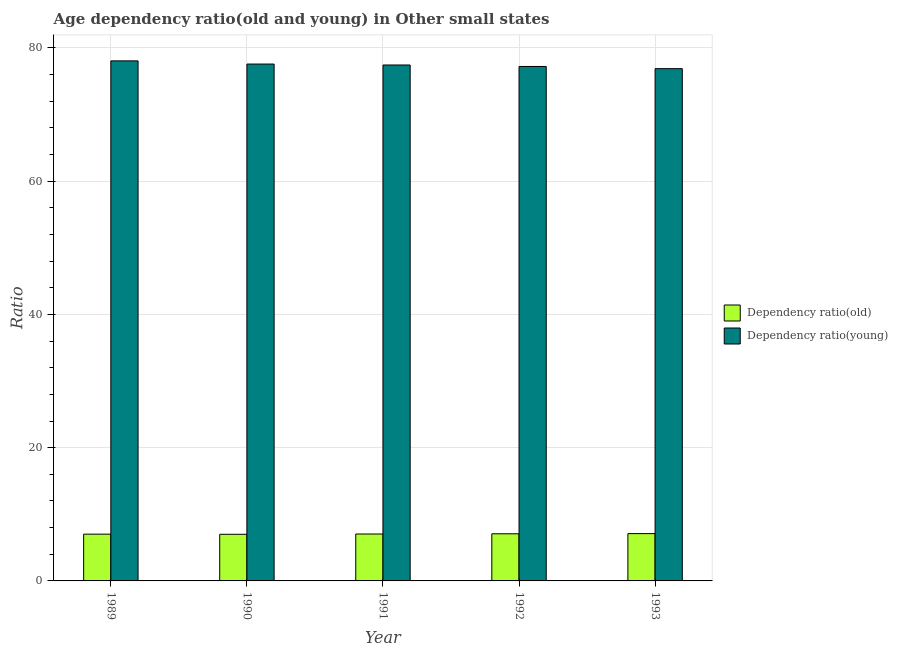How many different coloured bars are there?
Offer a terse response. 2. How many bars are there on the 4th tick from the left?
Make the answer very short. 2. What is the age dependency ratio(young) in 1991?
Provide a succinct answer. 77.45. Across all years, what is the maximum age dependency ratio(young)?
Make the answer very short. 78.07. Across all years, what is the minimum age dependency ratio(old)?
Ensure brevity in your answer.  7. In which year was the age dependency ratio(young) maximum?
Make the answer very short. 1989. What is the total age dependency ratio(young) in the graph?
Your answer should be very brief. 387.23. What is the difference between the age dependency ratio(old) in 1989 and that in 1990?
Give a very brief answer. 0.02. What is the difference between the age dependency ratio(old) in 1992 and the age dependency ratio(young) in 1989?
Give a very brief answer. 0.05. What is the average age dependency ratio(old) per year?
Your answer should be compact. 7.05. In how many years, is the age dependency ratio(old) greater than 24?
Your response must be concise. 0. What is the ratio of the age dependency ratio(old) in 1989 to that in 1990?
Provide a succinct answer. 1. Is the age dependency ratio(old) in 1991 less than that in 1992?
Keep it short and to the point. Yes. Is the difference between the age dependency ratio(old) in 1990 and 1991 greater than the difference between the age dependency ratio(young) in 1990 and 1991?
Provide a succinct answer. No. What is the difference between the highest and the second highest age dependency ratio(old)?
Your response must be concise. 0.02. What is the difference between the highest and the lowest age dependency ratio(young)?
Make the answer very short. 1.17. In how many years, is the age dependency ratio(old) greater than the average age dependency ratio(old) taken over all years?
Keep it short and to the point. 2. Is the sum of the age dependency ratio(old) in 1989 and 1990 greater than the maximum age dependency ratio(young) across all years?
Offer a very short reply. Yes. What does the 1st bar from the left in 1991 represents?
Offer a terse response. Dependency ratio(old). What does the 2nd bar from the right in 1993 represents?
Your answer should be compact. Dependency ratio(old). How many bars are there?
Your answer should be very brief. 10. Are all the bars in the graph horizontal?
Offer a very short reply. No. How many years are there in the graph?
Your answer should be compact. 5. What is the difference between two consecutive major ticks on the Y-axis?
Keep it short and to the point. 20. Does the graph contain any zero values?
Your answer should be very brief. No. Where does the legend appear in the graph?
Your response must be concise. Center right. How many legend labels are there?
Offer a very short reply. 2. What is the title of the graph?
Your answer should be very brief. Age dependency ratio(old and young) in Other small states. Does "Overweight" appear as one of the legend labels in the graph?
Offer a terse response. No. What is the label or title of the Y-axis?
Provide a short and direct response. Ratio. What is the Ratio in Dependency ratio(old) in 1989?
Give a very brief answer. 7.02. What is the Ratio in Dependency ratio(young) in 1989?
Offer a terse response. 78.07. What is the Ratio in Dependency ratio(old) in 1990?
Your answer should be very brief. 7. What is the Ratio in Dependency ratio(young) in 1990?
Offer a terse response. 77.59. What is the Ratio in Dependency ratio(old) in 1991?
Keep it short and to the point. 7.04. What is the Ratio of Dependency ratio(young) in 1991?
Offer a very short reply. 77.45. What is the Ratio of Dependency ratio(old) in 1992?
Make the answer very short. 7.08. What is the Ratio in Dependency ratio(young) in 1992?
Your response must be concise. 77.23. What is the Ratio in Dependency ratio(old) in 1993?
Offer a very short reply. 7.1. What is the Ratio in Dependency ratio(young) in 1993?
Provide a short and direct response. 76.9. Across all years, what is the maximum Ratio of Dependency ratio(old)?
Provide a short and direct response. 7.1. Across all years, what is the maximum Ratio in Dependency ratio(young)?
Provide a short and direct response. 78.07. Across all years, what is the minimum Ratio of Dependency ratio(old)?
Keep it short and to the point. 7. Across all years, what is the minimum Ratio of Dependency ratio(young)?
Keep it short and to the point. 76.9. What is the total Ratio of Dependency ratio(old) in the graph?
Keep it short and to the point. 35.24. What is the total Ratio in Dependency ratio(young) in the graph?
Give a very brief answer. 387.23. What is the difference between the Ratio of Dependency ratio(old) in 1989 and that in 1990?
Provide a short and direct response. 0.02. What is the difference between the Ratio of Dependency ratio(young) in 1989 and that in 1990?
Provide a short and direct response. 0.48. What is the difference between the Ratio in Dependency ratio(old) in 1989 and that in 1991?
Your answer should be compact. -0.02. What is the difference between the Ratio in Dependency ratio(young) in 1989 and that in 1991?
Provide a succinct answer. 0.62. What is the difference between the Ratio of Dependency ratio(old) in 1989 and that in 1992?
Provide a succinct answer. -0.05. What is the difference between the Ratio in Dependency ratio(young) in 1989 and that in 1992?
Give a very brief answer. 0.84. What is the difference between the Ratio in Dependency ratio(old) in 1989 and that in 1993?
Make the answer very short. -0.08. What is the difference between the Ratio of Dependency ratio(young) in 1989 and that in 1993?
Make the answer very short. 1.17. What is the difference between the Ratio in Dependency ratio(old) in 1990 and that in 1991?
Ensure brevity in your answer.  -0.04. What is the difference between the Ratio of Dependency ratio(young) in 1990 and that in 1991?
Keep it short and to the point. 0.14. What is the difference between the Ratio in Dependency ratio(old) in 1990 and that in 1992?
Provide a short and direct response. -0.08. What is the difference between the Ratio in Dependency ratio(young) in 1990 and that in 1992?
Your response must be concise. 0.37. What is the difference between the Ratio in Dependency ratio(old) in 1990 and that in 1993?
Your response must be concise. -0.1. What is the difference between the Ratio of Dependency ratio(young) in 1990 and that in 1993?
Your response must be concise. 0.69. What is the difference between the Ratio in Dependency ratio(old) in 1991 and that in 1992?
Offer a very short reply. -0.03. What is the difference between the Ratio in Dependency ratio(young) in 1991 and that in 1992?
Offer a very short reply. 0.22. What is the difference between the Ratio of Dependency ratio(old) in 1991 and that in 1993?
Make the answer very short. -0.06. What is the difference between the Ratio in Dependency ratio(young) in 1991 and that in 1993?
Provide a short and direct response. 0.55. What is the difference between the Ratio in Dependency ratio(old) in 1992 and that in 1993?
Offer a terse response. -0.02. What is the difference between the Ratio of Dependency ratio(young) in 1992 and that in 1993?
Make the answer very short. 0.33. What is the difference between the Ratio in Dependency ratio(old) in 1989 and the Ratio in Dependency ratio(young) in 1990?
Keep it short and to the point. -70.57. What is the difference between the Ratio of Dependency ratio(old) in 1989 and the Ratio of Dependency ratio(young) in 1991?
Provide a short and direct response. -70.43. What is the difference between the Ratio in Dependency ratio(old) in 1989 and the Ratio in Dependency ratio(young) in 1992?
Make the answer very short. -70.2. What is the difference between the Ratio in Dependency ratio(old) in 1989 and the Ratio in Dependency ratio(young) in 1993?
Give a very brief answer. -69.88. What is the difference between the Ratio in Dependency ratio(old) in 1990 and the Ratio in Dependency ratio(young) in 1991?
Your answer should be very brief. -70.45. What is the difference between the Ratio in Dependency ratio(old) in 1990 and the Ratio in Dependency ratio(young) in 1992?
Provide a succinct answer. -70.23. What is the difference between the Ratio in Dependency ratio(old) in 1990 and the Ratio in Dependency ratio(young) in 1993?
Provide a short and direct response. -69.9. What is the difference between the Ratio in Dependency ratio(old) in 1991 and the Ratio in Dependency ratio(young) in 1992?
Ensure brevity in your answer.  -70.18. What is the difference between the Ratio in Dependency ratio(old) in 1991 and the Ratio in Dependency ratio(young) in 1993?
Ensure brevity in your answer.  -69.86. What is the difference between the Ratio in Dependency ratio(old) in 1992 and the Ratio in Dependency ratio(young) in 1993?
Your answer should be compact. -69.82. What is the average Ratio in Dependency ratio(old) per year?
Ensure brevity in your answer.  7.05. What is the average Ratio in Dependency ratio(young) per year?
Provide a succinct answer. 77.45. In the year 1989, what is the difference between the Ratio in Dependency ratio(old) and Ratio in Dependency ratio(young)?
Provide a succinct answer. -71.05. In the year 1990, what is the difference between the Ratio of Dependency ratio(old) and Ratio of Dependency ratio(young)?
Offer a terse response. -70.59. In the year 1991, what is the difference between the Ratio in Dependency ratio(old) and Ratio in Dependency ratio(young)?
Keep it short and to the point. -70.41. In the year 1992, what is the difference between the Ratio in Dependency ratio(old) and Ratio in Dependency ratio(young)?
Offer a very short reply. -70.15. In the year 1993, what is the difference between the Ratio in Dependency ratio(old) and Ratio in Dependency ratio(young)?
Offer a terse response. -69.8. What is the ratio of the Ratio in Dependency ratio(young) in 1989 to that in 1991?
Keep it short and to the point. 1.01. What is the ratio of the Ratio of Dependency ratio(old) in 1989 to that in 1992?
Provide a short and direct response. 0.99. What is the ratio of the Ratio in Dependency ratio(young) in 1989 to that in 1992?
Provide a short and direct response. 1.01. What is the ratio of the Ratio in Dependency ratio(old) in 1989 to that in 1993?
Offer a terse response. 0.99. What is the ratio of the Ratio in Dependency ratio(young) in 1989 to that in 1993?
Ensure brevity in your answer.  1.02. What is the ratio of the Ratio of Dependency ratio(old) in 1990 to that in 1991?
Make the answer very short. 0.99. What is the ratio of the Ratio of Dependency ratio(young) in 1990 to that in 1991?
Your answer should be compact. 1. What is the ratio of the Ratio in Dependency ratio(old) in 1990 to that in 1992?
Keep it short and to the point. 0.99. What is the ratio of the Ratio of Dependency ratio(young) in 1990 to that in 1992?
Ensure brevity in your answer.  1. What is the ratio of the Ratio of Dependency ratio(old) in 1990 to that in 1993?
Provide a succinct answer. 0.99. What is the ratio of the Ratio of Dependency ratio(young) in 1990 to that in 1993?
Your answer should be very brief. 1.01. What is the ratio of the Ratio in Dependency ratio(old) in 1991 to that in 1993?
Provide a succinct answer. 0.99. What is the ratio of the Ratio of Dependency ratio(young) in 1991 to that in 1993?
Your answer should be very brief. 1.01. What is the ratio of the Ratio in Dependency ratio(old) in 1992 to that in 1993?
Your answer should be compact. 1. What is the ratio of the Ratio of Dependency ratio(young) in 1992 to that in 1993?
Offer a very short reply. 1. What is the difference between the highest and the second highest Ratio in Dependency ratio(old)?
Provide a succinct answer. 0.02. What is the difference between the highest and the second highest Ratio of Dependency ratio(young)?
Your answer should be compact. 0.48. What is the difference between the highest and the lowest Ratio of Dependency ratio(old)?
Your answer should be very brief. 0.1. What is the difference between the highest and the lowest Ratio in Dependency ratio(young)?
Give a very brief answer. 1.17. 